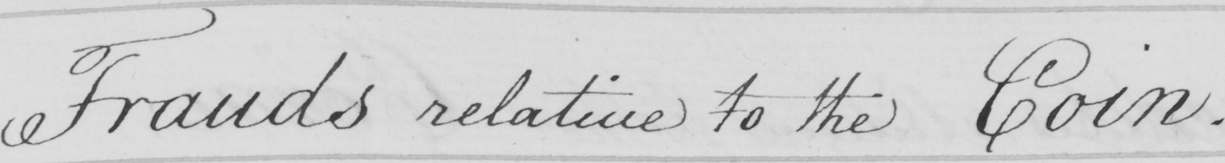Please provide the text content of this handwritten line. Frauds relative to the Coin . 